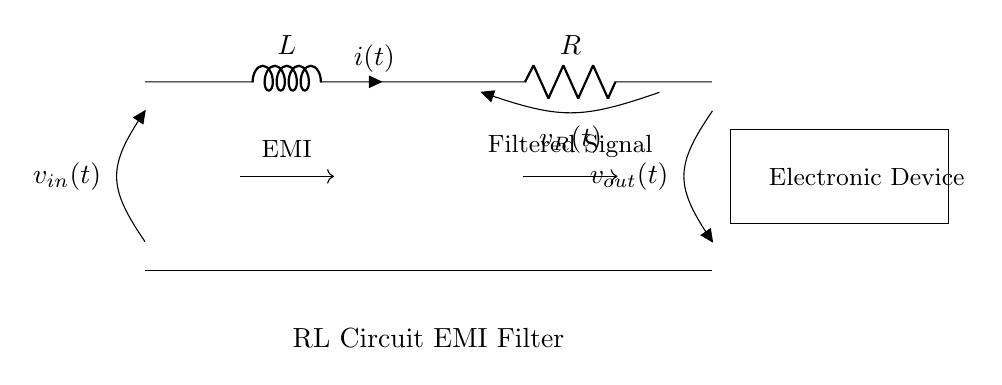What components are present in the circuit? The circuit contains an inductor (L) and a resistor (R). These are the two primary components that play a crucial role in the functioning of the RL circuit.
Answer: Inductor and Resistor What is the input voltage in the circuit? The input voltage is represented as v_in(t) and is located at the top left of the diagram. This indicates the voltage entering the circuit from an external source.
Answer: v_in(t) What current flows through the inductor? The current flowing through the inductor is indicated as i(t). This label is present next to the inductor symbol in the diagram, illustrating the current direction.
Answer: i(t) What does the filtered signal refer to in this circuit? The filtered signal is the output voltage indicated as v_out(t), which occurs after the signal has passed through the inductor and resistor components. It represents the output of the EMI filter.
Answer: v_out(t) How does this RL circuit help with electromagnetic interference? The RL circuit smooths out fluctuations in current and voltage, thereby filtering out high-frequency noise or spikes, which is the essence of an EMI filter. The presence of inductance helps oppose changes in current, providing effective filtering.
Answer: Smooths out fluctuations What is the role of the resistor in the circuit? The resistor (R) dissipates energy as heat and contributes to the overall impedance of the circuit. This damping effect helps in controlling the current flow through the circuit, which is essential for proper filtering.
Answer: Damps the current 